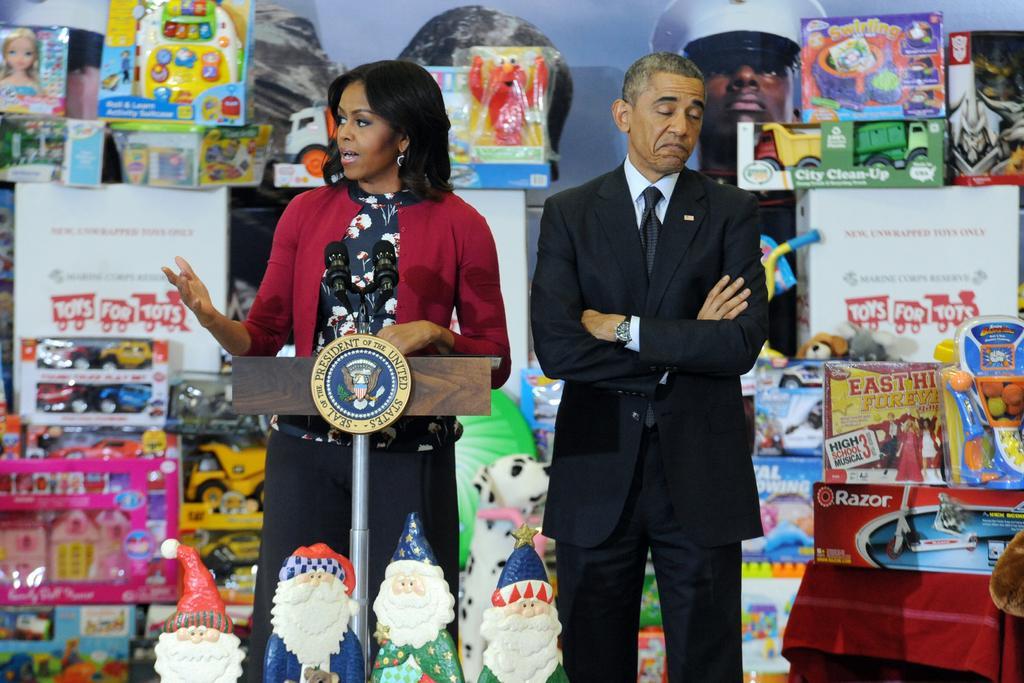Describe this image in one or two sentences. In this picture I can see e a woman speaking into microphone, beside her there is a man in the middle. In the background I can see many toys. 